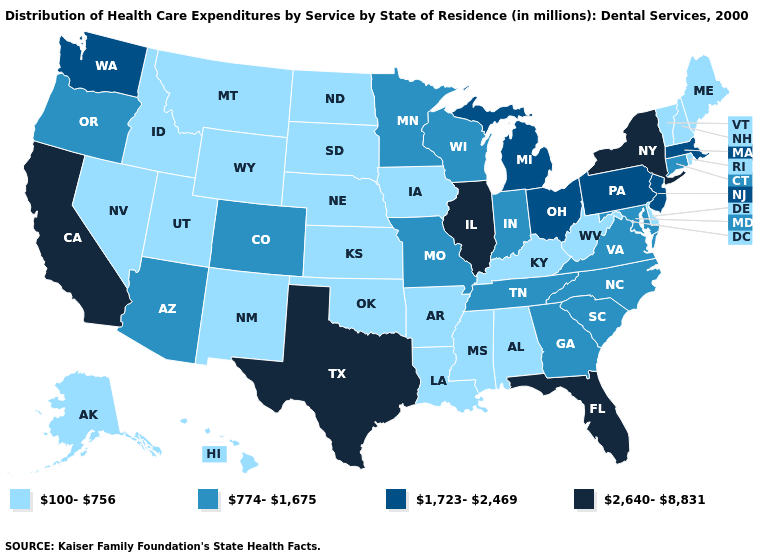Among the states that border Rhode Island , which have the lowest value?
Short answer required. Connecticut. What is the value of Mississippi?
Give a very brief answer. 100-756. Does Minnesota have a lower value than Michigan?
Be succinct. Yes. What is the highest value in the USA?
Answer briefly. 2,640-8,831. What is the value of Pennsylvania?
Short answer required. 1,723-2,469. What is the value of New York?
Concise answer only. 2,640-8,831. What is the value of Kansas?
Keep it brief. 100-756. Name the states that have a value in the range 100-756?
Write a very short answer. Alabama, Alaska, Arkansas, Delaware, Hawaii, Idaho, Iowa, Kansas, Kentucky, Louisiana, Maine, Mississippi, Montana, Nebraska, Nevada, New Hampshire, New Mexico, North Dakota, Oklahoma, Rhode Island, South Dakota, Utah, Vermont, West Virginia, Wyoming. Does Wyoming have the lowest value in the USA?
Write a very short answer. Yes. How many symbols are there in the legend?
Quick response, please. 4. Among the states that border Montana , which have the lowest value?
Answer briefly. Idaho, North Dakota, South Dakota, Wyoming. Name the states that have a value in the range 774-1,675?
Quick response, please. Arizona, Colorado, Connecticut, Georgia, Indiana, Maryland, Minnesota, Missouri, North Carolina, Oregon, South Carolina, Tennessee, Virginia, Wisconsin. What is the lowest value in the USA?
Be succinct. 100-756. Name the states that have a value in the range 2,640-8,831?
Be succinct. California, Florida, Illinois, New York, Texas. What is the value of North Carolina?
Answer briefly. 774-1,675. 